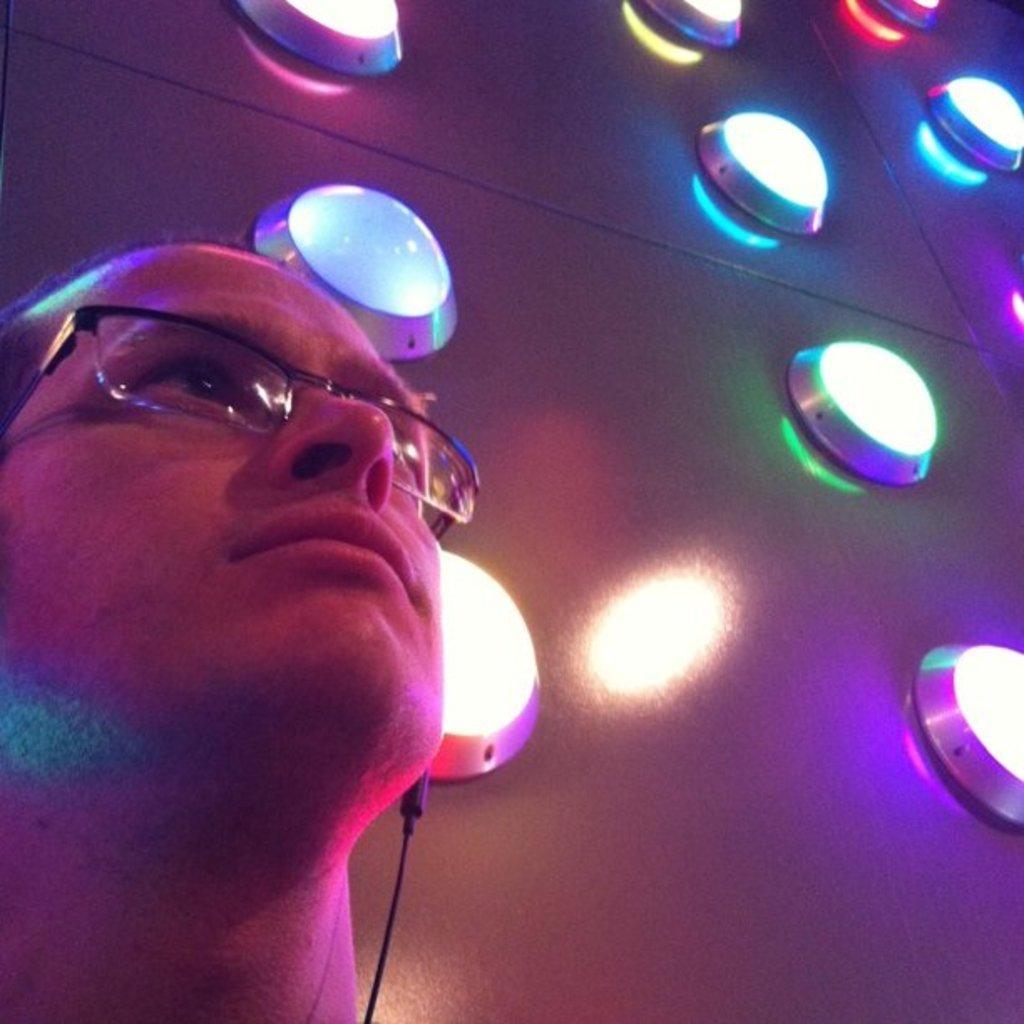Could you give a brief overview of what you see in this image? In this picture I can see a man on the left side wearing spectacles. I can see decorative lights on the right side. 